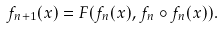Convert formula to latex. <formula><loc_0><loc_0><loc_500><loc_500>f _ { n + 1 } ( x ) = F ( f _ { n } ( x ) , f _ { n } \circ f _ { n } ( x ) ) .</formula> 